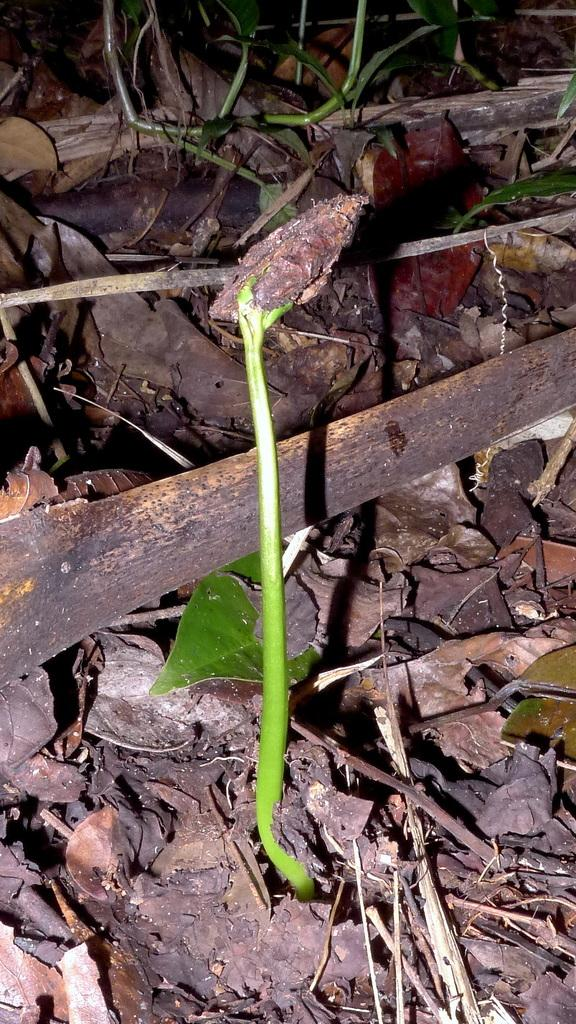What type of plant can be seen in the image? There is a small growing plant in the image. What part of the plant is visible in the image? Leaves are visible in the image. What material are the sticks made of in the image? The sticks in the image are made of wood. What type of balls can be seen bouncing around the plant in the image? There are no balls present in the image; it only features a small growing plant with leaves and wooden sticks. 